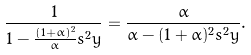<formula> <loc_0><loc_0><loc_500><loc_500>\frac { 1 } { 1 - \frac { ( 1 + \alpha ) ^ { 2 } } { \alpha } s ^ { 2 } y } & = \frac { \alpha } { \alpha - ( 1 + \alpha ) ^ { 2 } s ^ { 2 } y } .</formula> 